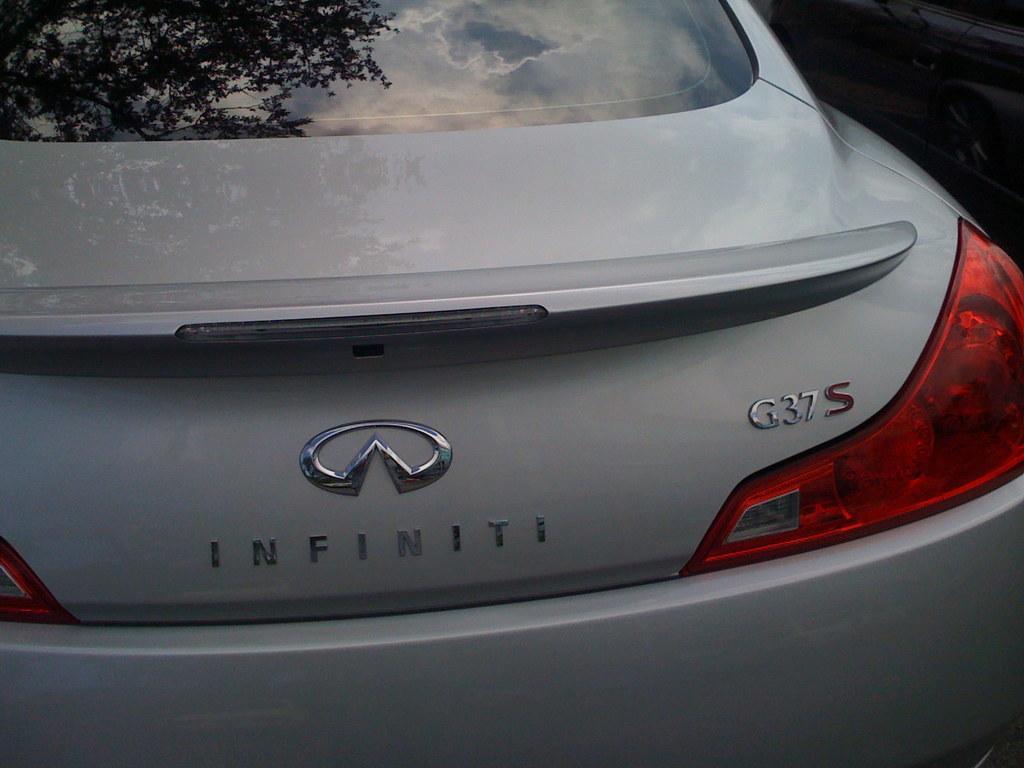Please provide a concise description of this image. In the center of the image we can see white colored car. 